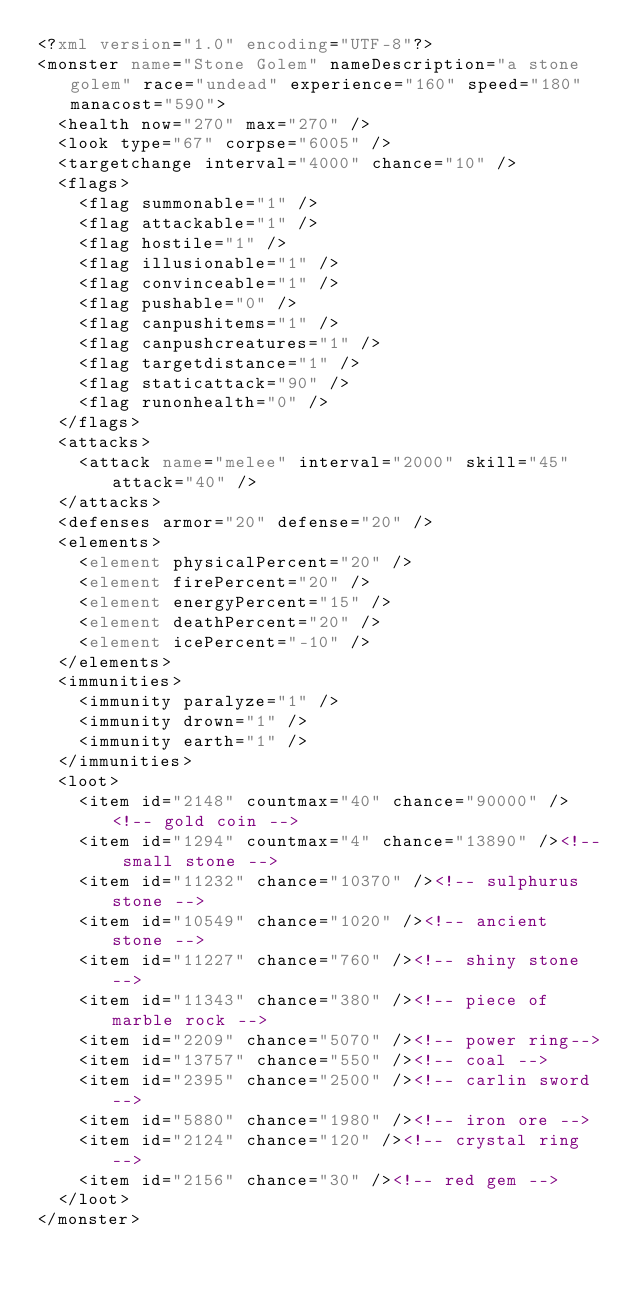<code> <loc_0><loc_0><loc_500><loc_500><_XML_><?xml version="1.0" encoding="UTF-8"?>
<monster name="Stone Golem" nameDescription="a stone golem" race="undead" experience="160" speed="180" manacost="590">
	<health now="270" max="270" />
	<look type="67" corpse="6005" />
	<targetchange interval="4000" chance="10" />
	<flags>
		<flag summonable="1" />
		<flag attackable="1" />
		<flag hostile="1" />
		<flag illusionable="1" />
		<flag convinceable="1" />
		<flag pushable="0" />
		<flag canpushitems="1" />
		<flag canpushcreatures="1" />
		<flag targetdistance="1" />
		<flag staticattack="90" />
		<flag runonhealth="0" />
	</flags>
	<attacks>
		<attack name="melee" interval="2000" skill="45" attack="40" />
	</attacks>
	<defenses armor="20" defense="20" />
	<elements>
		<element physicalPercent="20" />
		<element firePercent="20" />
		<element energyPercent="15" />
		<element deathPercent="20" />
		<element icePercent="-10" />
	</elements>
	<immunities>
		<immunity paralyze="1" />
		<immunity drown="1" />
		<immunity earth="1" />
	</immunities>
	<loot>
		<item id="2148" countmax="40" chance="90000" /><!-- gold coin -->
		<item id="1294" countmax="4" chance="13890" /><!-- small stone -->
		<item id="11232" chance="10370" /><!-- sulphurus stone -->
		<item id="10549" chance="1020" /><!-- ancient stone -->
		<item id="11227" chance="760" /><!-- shiny stone -->
		<item id="11343" chance="380" /><!-- piece of marble rock -->
		<item id="2209" chance="5070" /><!-- power ring-->
		<item id="13757" chance="550" /><!-- coal -->
		<item id="2395" chance="2500" /><!-- carlin sword -->
		<item id="5880" chance="1980" /><!-- iron ore -->
		<item id="2124" chance="120" /><!-- crystal ring -->
		<item id="2156" chance="30" /><!-- red gem -->
	</loot>
</monster>
</code> 